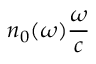<formula> <loc_0><loc_0><loc_500><loc_500>n _ { 0 } ( \omega ) \frac { \omega } { c }</formula> 